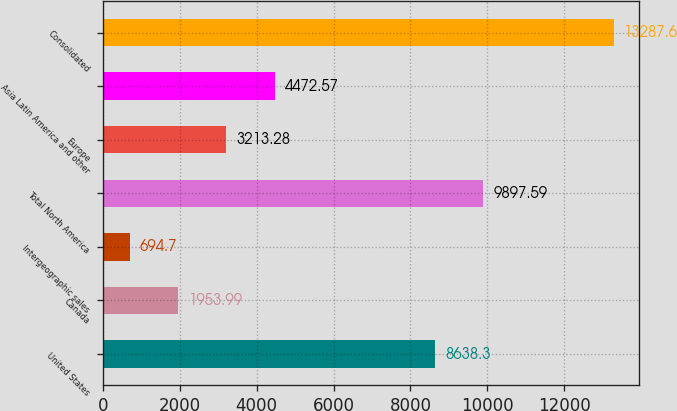<chart> <loc_0><loc_0><loc_500><loc_500><bar_chart><fcel>United States<fcel>Canada<fcel>Intergeographic sales<fcel>Total North America<fcel>Europe<fcel>Asia Latin America and other<fcel>Consolidated<nl><fcel>8638.3<fcel>1953.99<fcel>694.7<fcel>9897.59<fcel>3213.28<fcel>4472.57<fcel>13287.6<nl></chart> 